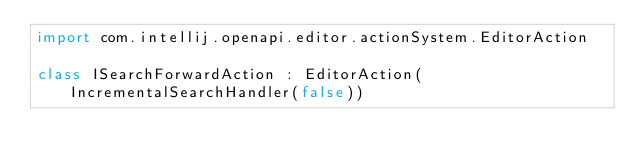<code> <loc_0><loc_0><loc_500><loc_500><_Kotlin_>import com.intellij.openapi.editor.actionSystem.EditorAction

class ISearchForwardAction : EditorAction(IncrementalSearchHandler(false))
</code> 